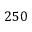<formula> <loc_0><loc_0><loc_500><loc_500>2 5 0</formula> 